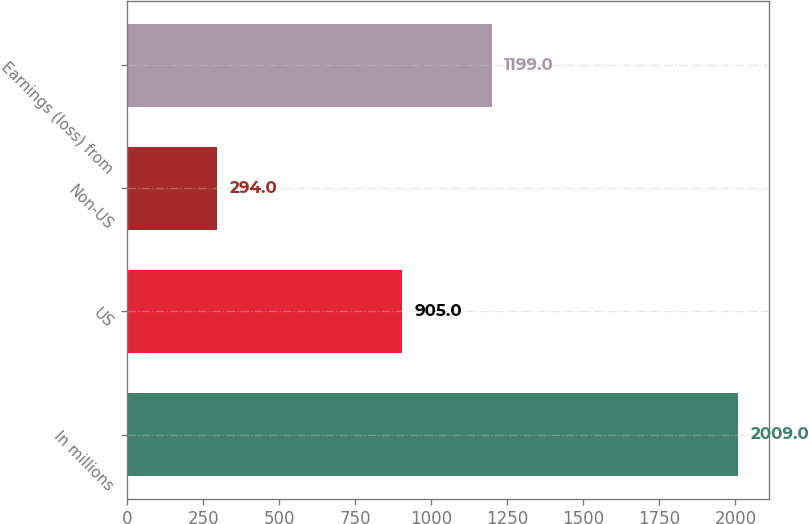Convert chart to OTSL. <chart><loc_0><loc_0><loc_500><loc_500><bar_chart><fcel>In millions<fcel>US<fcel>Non-US<fcel>Earnings (loss) from<nl><fcel>2009<fcel>905<fcel>294<fcel>1199<nl></chart> 